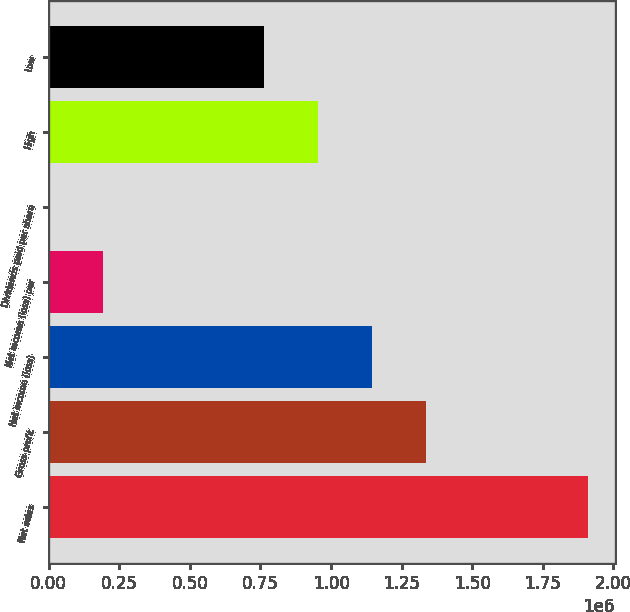Convert chart to OTSL. <chart><loc_0><loc_0><loc_500><loc_500><bar_chart><fcel>Net sales<fcel>Gross profit<fcel>Net income (loss)<fcel>Net income (loss) per<fcel>Dividends paid per share<fcel>High<fcel>Low<nl><fcel>1.90922e+06<fcel>1.33646e+06<fcel>1.14553e+06<fcel>190923<fcel>0.58<fcel>954611<fcel>763689<nl></chart> 